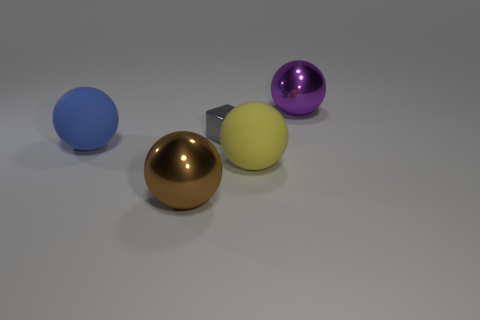There is a metal object in front of the big blue matte object; is it the same size as the gray thing right of the brown thing? While the metal object in front of the large blue spherical object has a similar appearance to the gray cube situated to the right of the brown sphere, it is not the same size. The gray cube is notably smaller than the metal object when comparing their dimensions. 